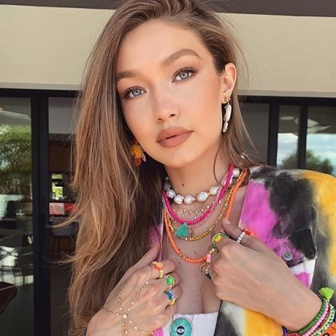What emotions do you think the woman is feeling? The woman appears to be experiencing a range of emotions, possibly a mixture of excitement and curiosity. Her expressive eyes and the gentle placement of her hands near her chest suggest she might be taken aback or pleasantly surprised. The direct gaze into the camera could also indicate a sense of confidence and connection with the viewer. 